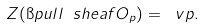Convert formula to latex. <formula><loc_0><loc_0><loc_500><loc_500>Z ( \i p u l l \ s h e a f { O } _ { p } ) = \ v p .</formula> 